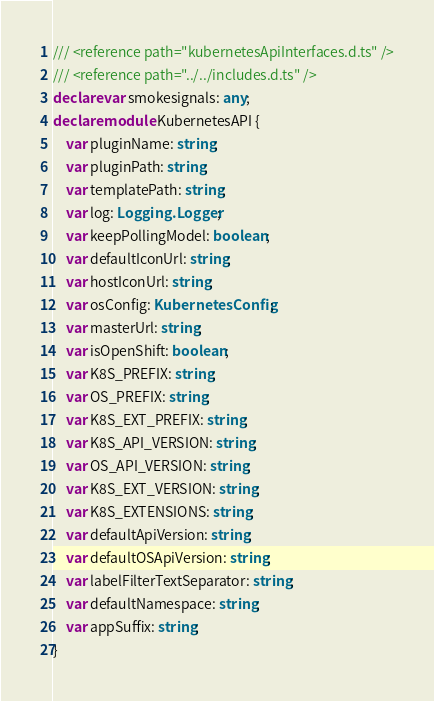<code> <loc_0><loc_0><loc_500><loc_500><_TypeScript_>/// <reference path="kubernetesApiInterfaces.d.ts" />
/// <reference path="../../includes.d.ts" />
declare var smokesignals: any;
declare module KubernetesAPI {
    var pluginName: string;
    var pluginPath: string;
    var templatePath: string;
    var log: Logging.Logger;
    var keepPollingModel: boolean;
    var defaultIconUrl: string;
    var hostIconUrl: string;
    var osConfig: KubernetesConfig;
    var masterUrl: string;
    var isOpenShift: boolean;
    var K8S_PREFIX: string;
    var OS_PREFIX: string;
    var K8S_EXT_PREFIX: string;
    var K8S_API_VERSION: string;
    var OS_API_VERSION: string;
    var K8S_EXT_VERSION: string;
    var K8S_EXTENSIONS: string;
    var defaultApiVersion: string;
    var defaultOSApiVersion: string;
    var labelFilterTextSeparator: string;
    var defaultNamespace: string;
    var appSuffix: string;
}
</code> 